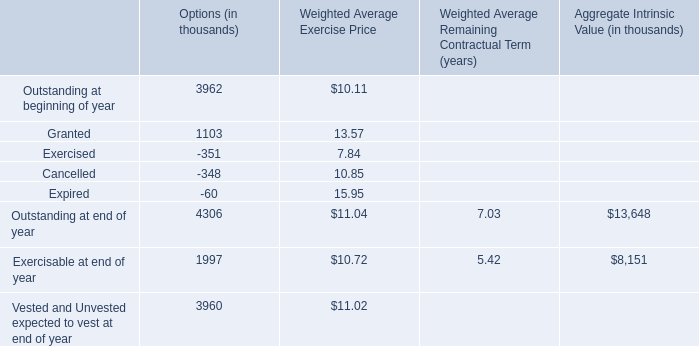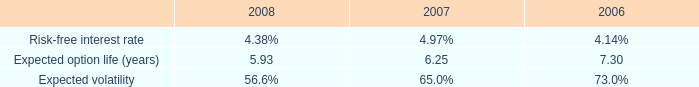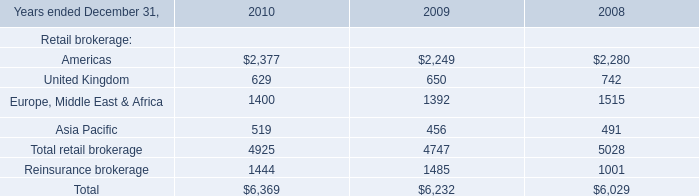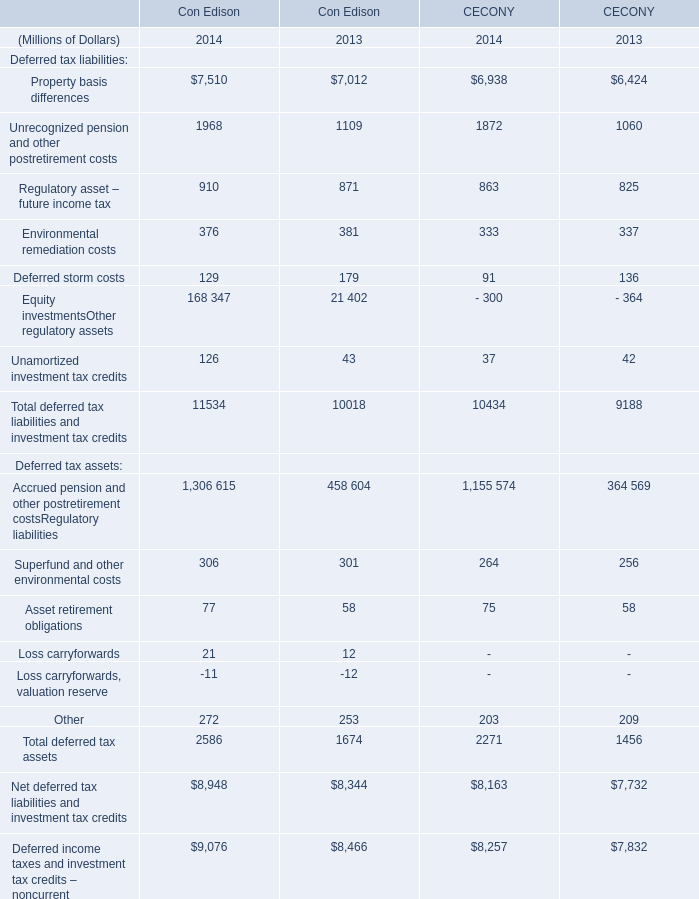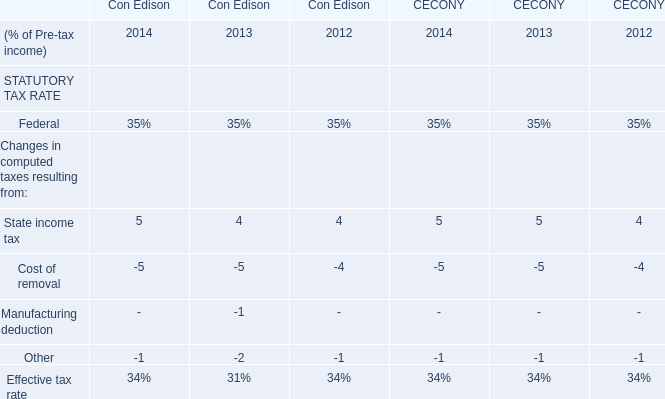What will Asset retirement obligations in terms of Con Edison reach in 2015 if it continues to grow at its current rate? (in million) 
Computations: (77 * (1 + ((77 - 58) / 58)))
Answer: 102.22414. 